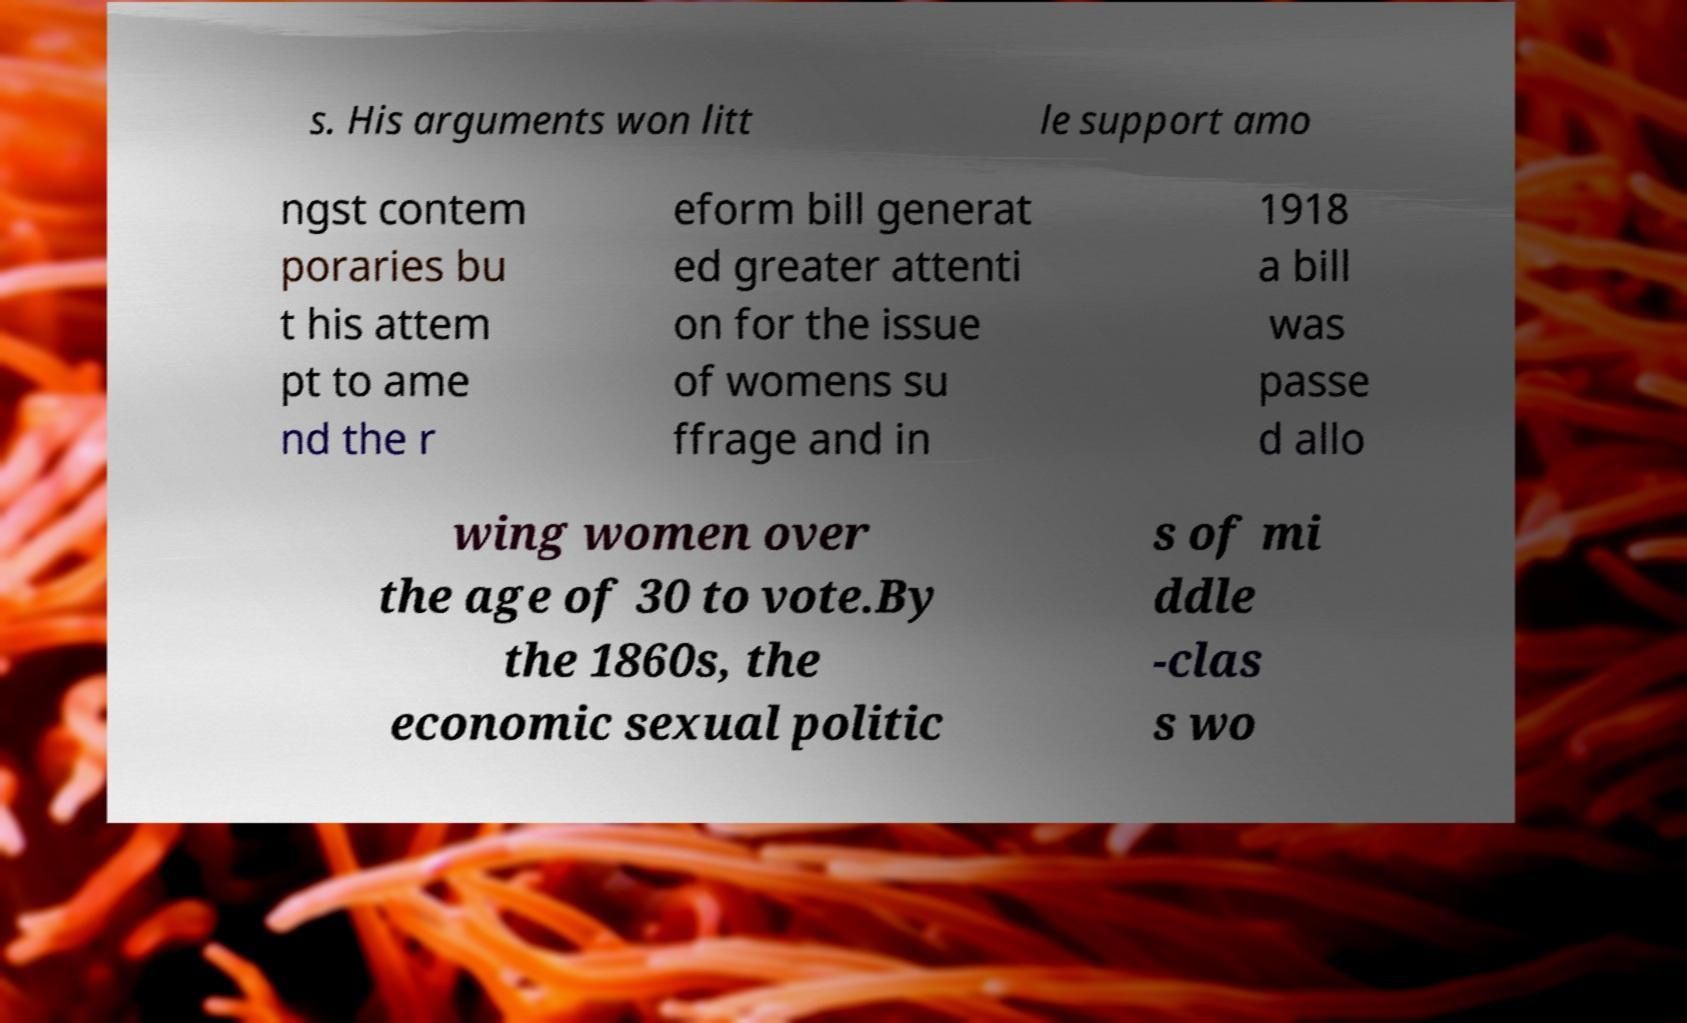Can you read and provide the text displayed in the image?This photo seems to have some interesting text. Can you extract and type it out for me? s. His arguments won litt le support amo ngst contem poraries bu t his attem pt to ame nd the r eform bill generat ed greater attenti on for the issue of womens su ffrage and in 1918 a bill was passe d allo wing women over the age of 30 to vote.By the 1860s, the economic sexual politic s of mi ddle -clas s wo 